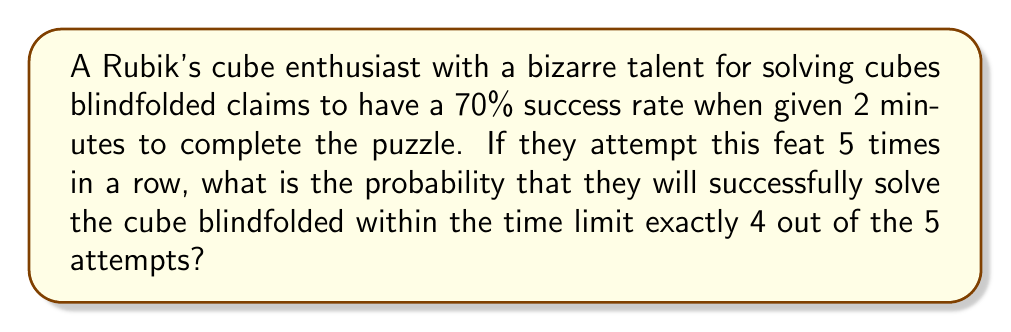Solve this math problem. To solve this problem, we need to use the binomial probability formula, as we are dealing with a fixed number of independent trials with two possible outcomes (success or failure) and a constant probability of success.

Let's define our variables:
$n = 5$ (number of attempts)
$k = 4$ (number of successful attempts we're interested in)
$p = 0.70$ (probability of success on each attempt)
$q = 1 - p = 0.30$ (probability of failure on each attempt)

The binomial probability formula is:

$$P(X = k) = \binom{n}{k} p^k q^{n-k}$$

Where $\binom{n}{k}$ is the binomial coefficient, calculated as:

$$\binom{n}{k} = \frac{n!}{k!(n-k)!}$$

Let's solve step by step:

1) Calculate the binomial coefficient:
   $$\binom{5}{4} = \frac{5!}{4!(5-4)!} = \frac{5!}{4!1!} = 5$$

2) Plug all values into the binomial probability formula:
   $$P(X = 4) = 5 \cdot (0.70)^4 \cdot (0.30)^{5-4}$$

3) Simplify:
   $$P(X = 4) = 5 \cdot (0.70)^4 \cdot (0.30)^1$$

4) Calculate:
   $$P(X = 4) = 5 \cdot 0.2401 \cdot 0.30 = 0.36015$$

Therefore, the probability of the enthusiast successfully solving the Rubik's cube blindfolded within the time limit exactly 4 out of 5 attempts is approximately 0.36015 or 36.015%.
Answer: The probability is approximately 0.36015 or 36.015%. 